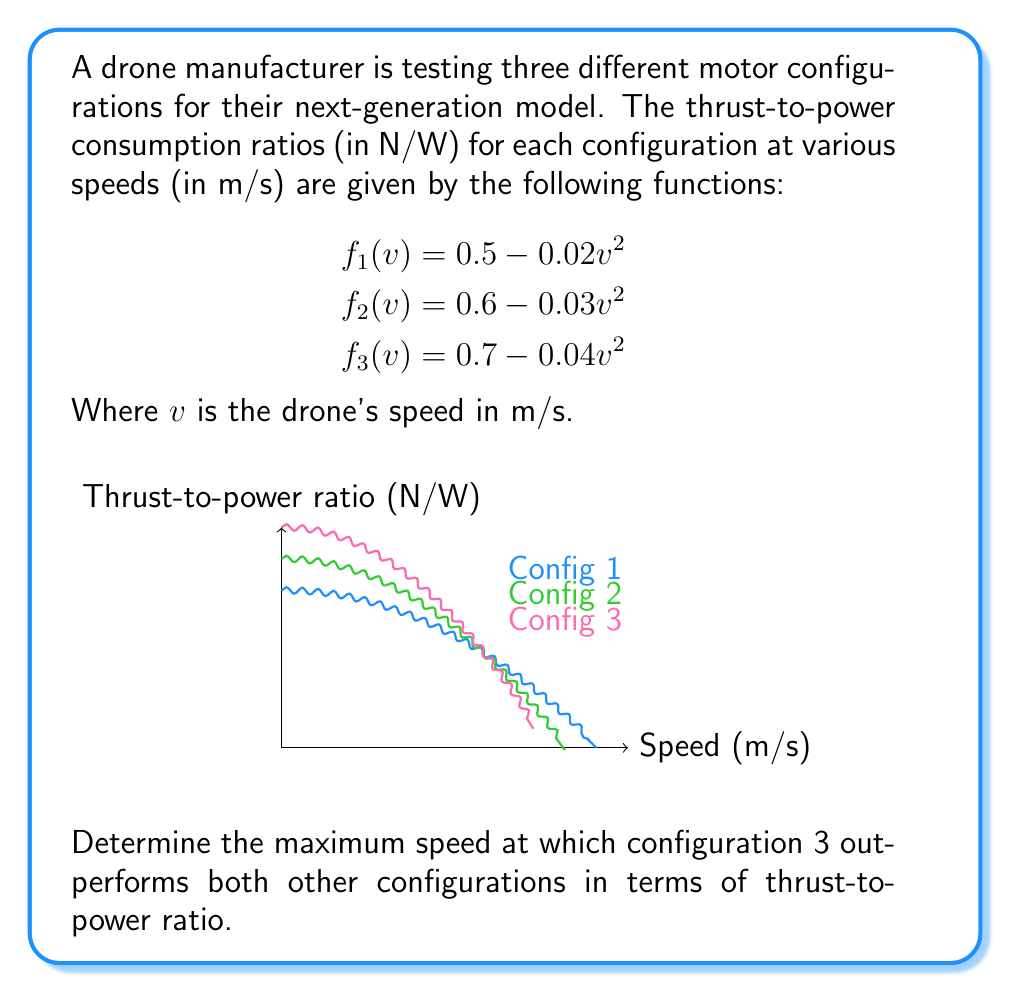Can you answer this question? To solve this problem, we need to find the point where configuration 3 intersects with the better of the other two configurations. Let's approach this step-by-step:

1) First, we need to determine which of configurations 1 and 2 is better at higher speeds. We can do this by finding their intersection point:

   $$0.5 - 0.02v^2 = 0.6 - 0.03v^2$$
   $$0.01v^2 = 0.1$$
   $$v^2 = 10$$
   $$v = \sqrt{10} \approx 3.16$$

2) Above this speed, configuration 1 is better than configuration 2. So, we need to find where configuration 3 intersects with configuration 1:

   $$0.5 - 0.02v^2 = 0.7 - 0.04v^2$$
   $$0.02v^2 = 0.2$$
   $$v^2 = 10$$
   $$v = \sqrt{10} \approx 3.16$$

3) This intersection point is exactly where configurations 1 and 2 intersect. This means that at this speed, all three configurations have the same thrust-to-power ratio.

4) To confirm that configuration 3 is indeed better below this speed, we can check its intersection with configuration 2:

   $$0.6 - 0.03v^2 = 0.7 - 0.04v^2$$
   $$0.01v^2 = 0.1$$
   $$v^2 = 10$$
   $$v = \sqrt{10} \approx 3.16$$

5) This is the same intersection point, confirming our analysis.

Therefore, configuration 3 outperforms both other configurations for all speeds below $\sqrt{10}$ m/s.
Answer: $\sqrt{10}$ m/s 